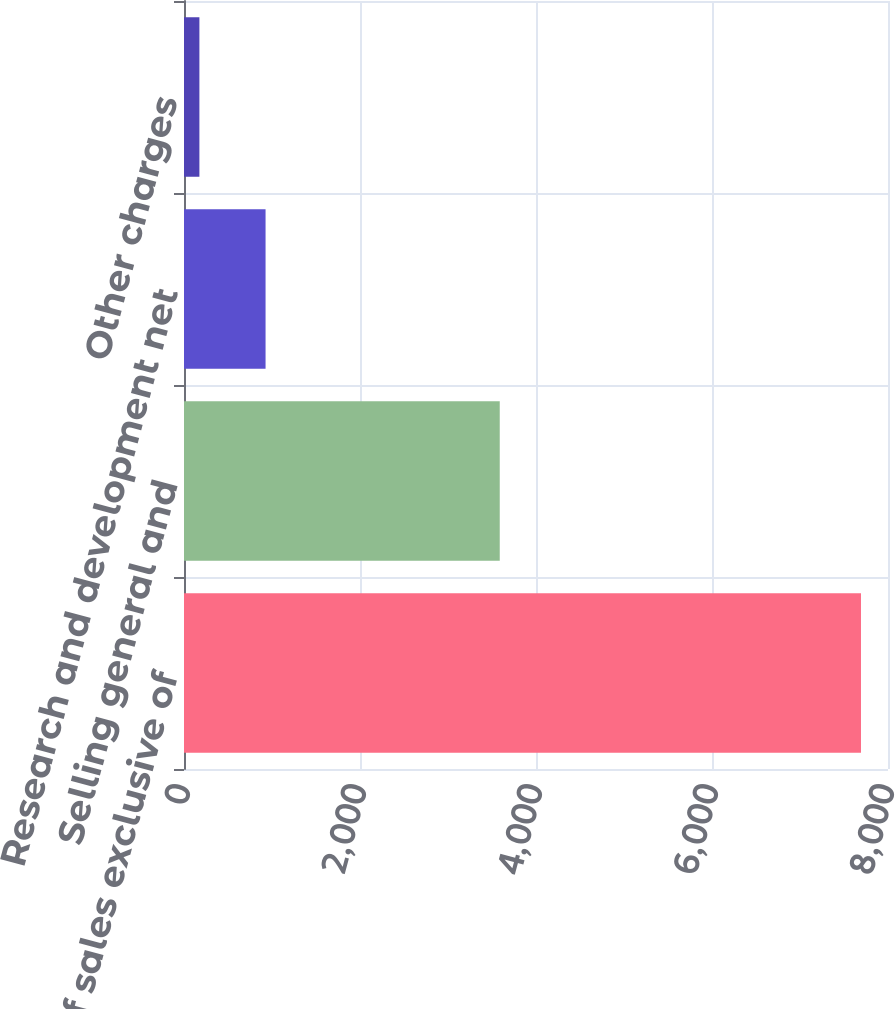<chart> <loc_0><loc_0><loc_500><loc_500><bar_chart><fcel>Cost of sales exclusive of<fcel>Selling general and<fcel>Research and development net<fcel>Other charges<nl><fcel>7693<fcel>3588<fcel>926.8<fcel>175<nl></chart> 